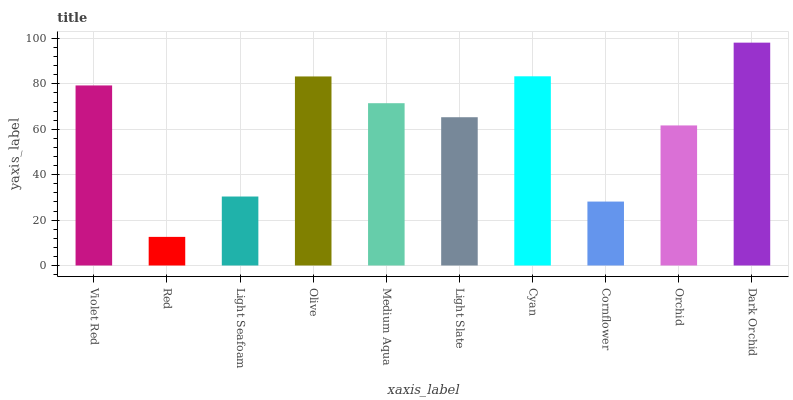Is Red the minimum?
Answer yes or no. Yes. Is Dark Orchid the maximum?
Answer yes or no. Yes. Is Light Seafoam the minimum?
Answer yes or no. No. Is Light Seafoam the maximum?
Answer yes or no. No. Is Light Seafoam greater than Red?
Answer yes or no. Yes. Is Red less than Light Seafoam?
Answer yes or no. Yes. Is Red greater than Light Seafoam?
Answer yes or no. No. Is Light Seafoam less than Red?
Answer yes or no. No. Is Medium Aqua the high median?
Answer yes or no. Yes. Is Light Slate the low median?
Answer yes or no. Yes. Is Olive the high median?
Answer yes or no. No. Is Orchid the low median?
Answer yes or no. No. 